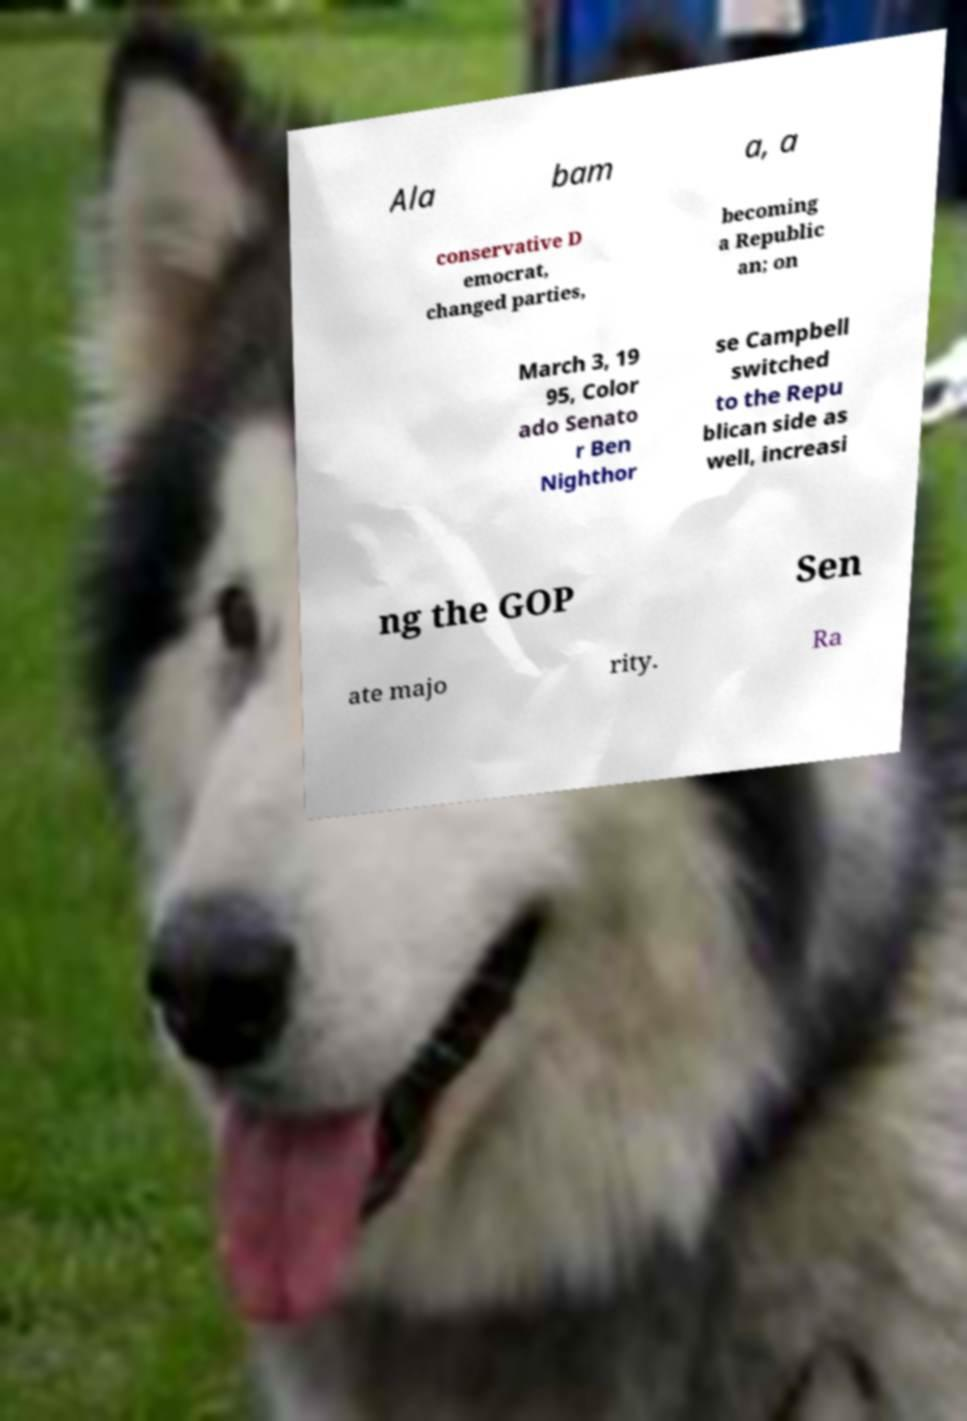Please read and relay the text visible in this image. What does it say? Ala bam a, a conservative D emocrat, changed parties, becoming a Republic an; on March 3, 19 95, Color ado Senato r Ben Nighthor se Campbell switched to the Repu blican side as well, increasi ng the GOP Sen ate majo rity. Ra 